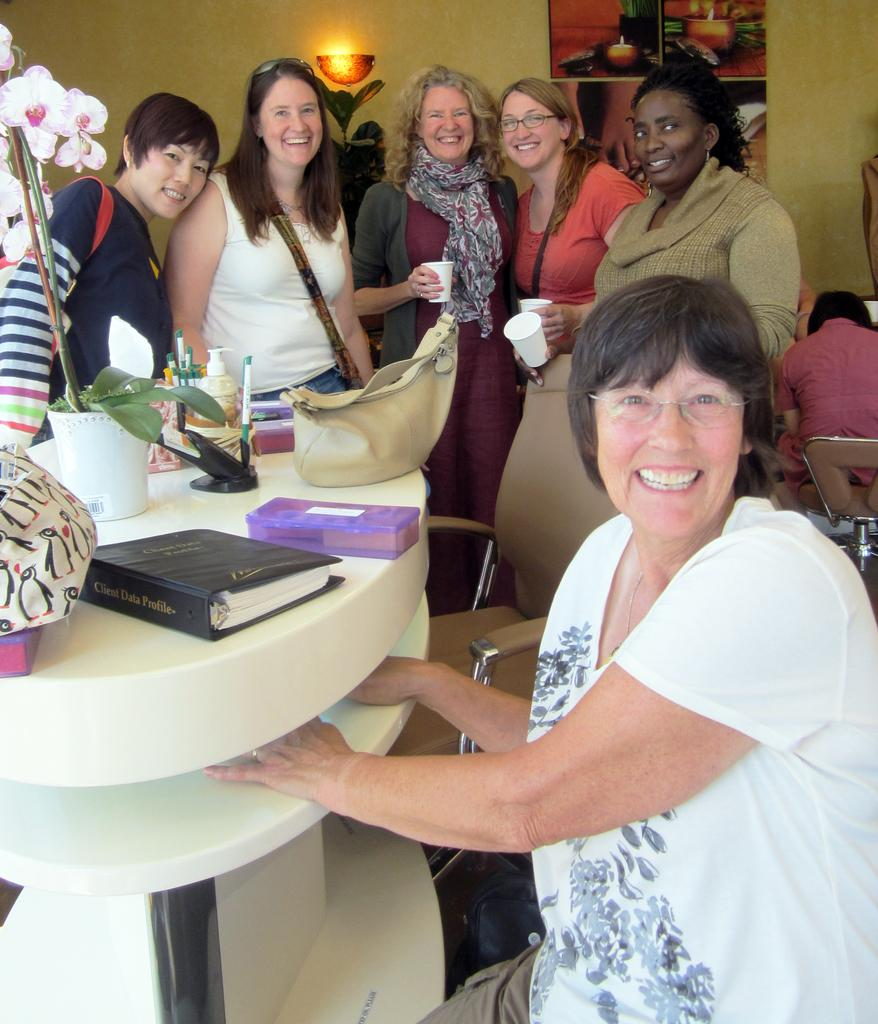<image>
Create a compact narrative representing the image presented. A group of women smile standing around a table with a Client Data Profile sitting on the table. 